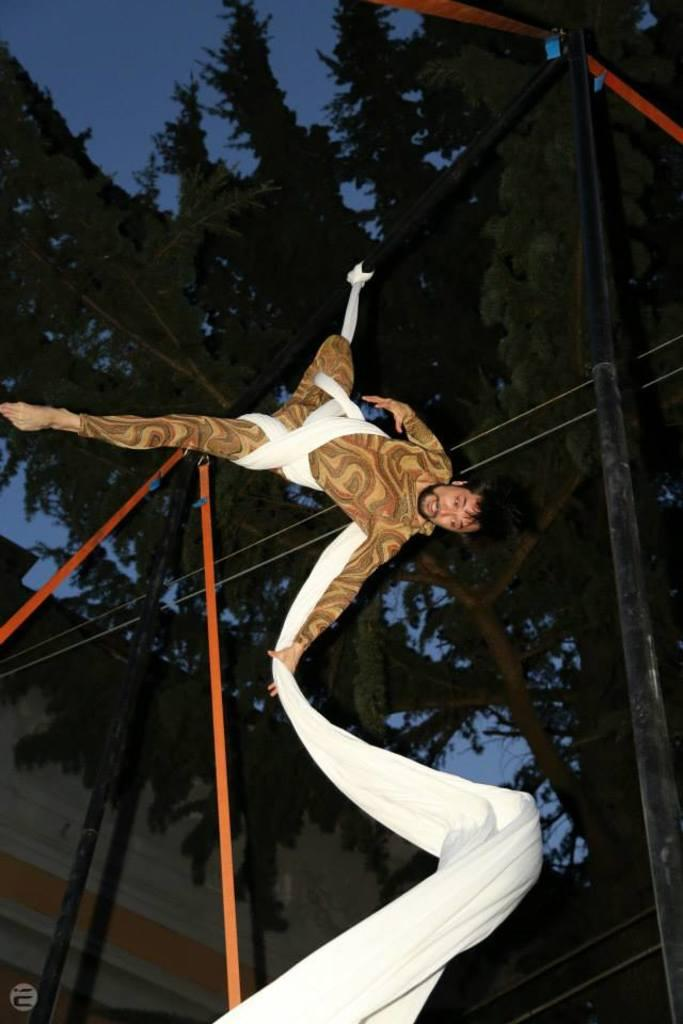What is the person in the image doing? The person is flying in the air in the image. What is the person holding while flying? The person is holding a white color cloth. What can be seen in the background of the image? There are trees and at least one building visible in the image. What is the color of the sky in the image? The sky is blue in color. What type of grip does the governor have on the leaf in the image? There is no governor or leaf present in the image; it features a person flying while holding a white color cloth. 